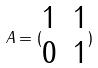Convert formula to latex. <formula><loc_0><loc_0><loc_500><loc_500>A = ( \begin{matrix} 1 & 1 \\ 0 & 1 \end{matrix} )</formula> 